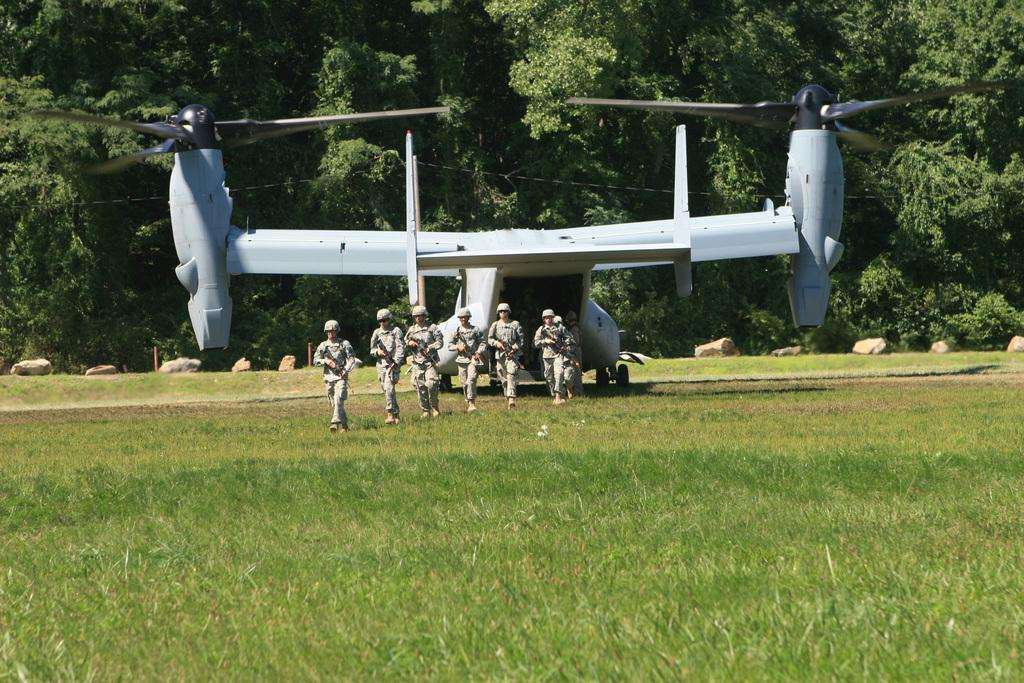Who or what can be seen in the image? There are people in the image. What are the people doing in the image? The people are walking on the grass and holding guns. What can be seen in the background of the image? There is a plane and trees visible in the background. What is the rate of the stone rolling down the hill in the image? There is no stone rolling down a hill in the image. The image features people walking on grass and holding guns, with a plane and trees visible in the background. 